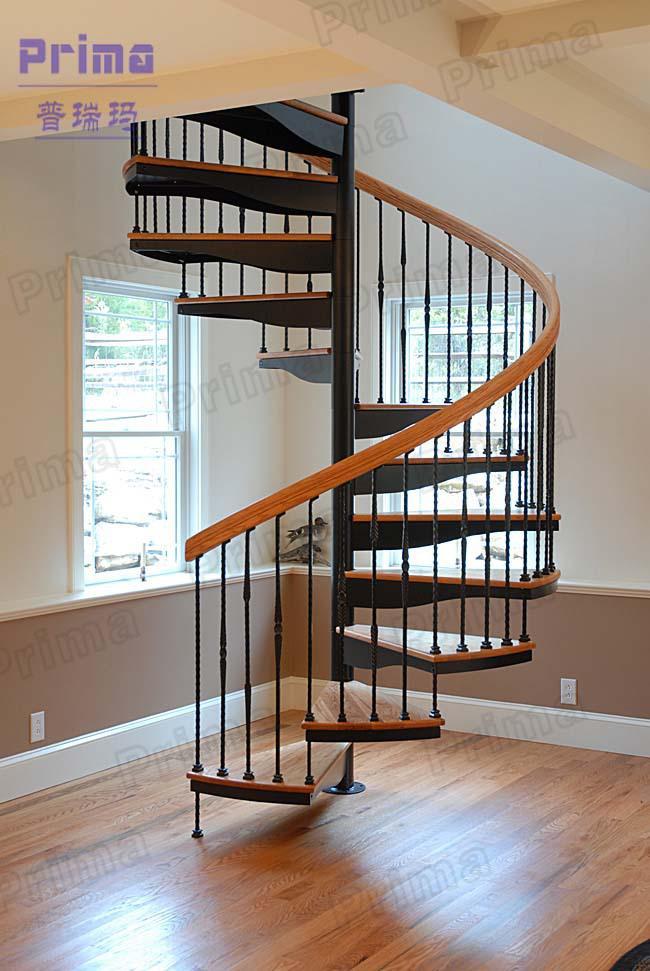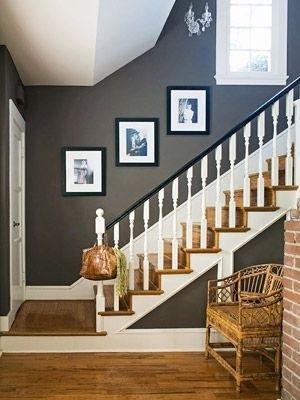The first image is the image on the left, the second image is the image on the right. Analyze the images presented: Is the assertion "In at least one image a there are three picture frames showing above a single stair case that faces left with the exception of 1 to 3 individual stairs." valid? Answer yes or no. Yes. 